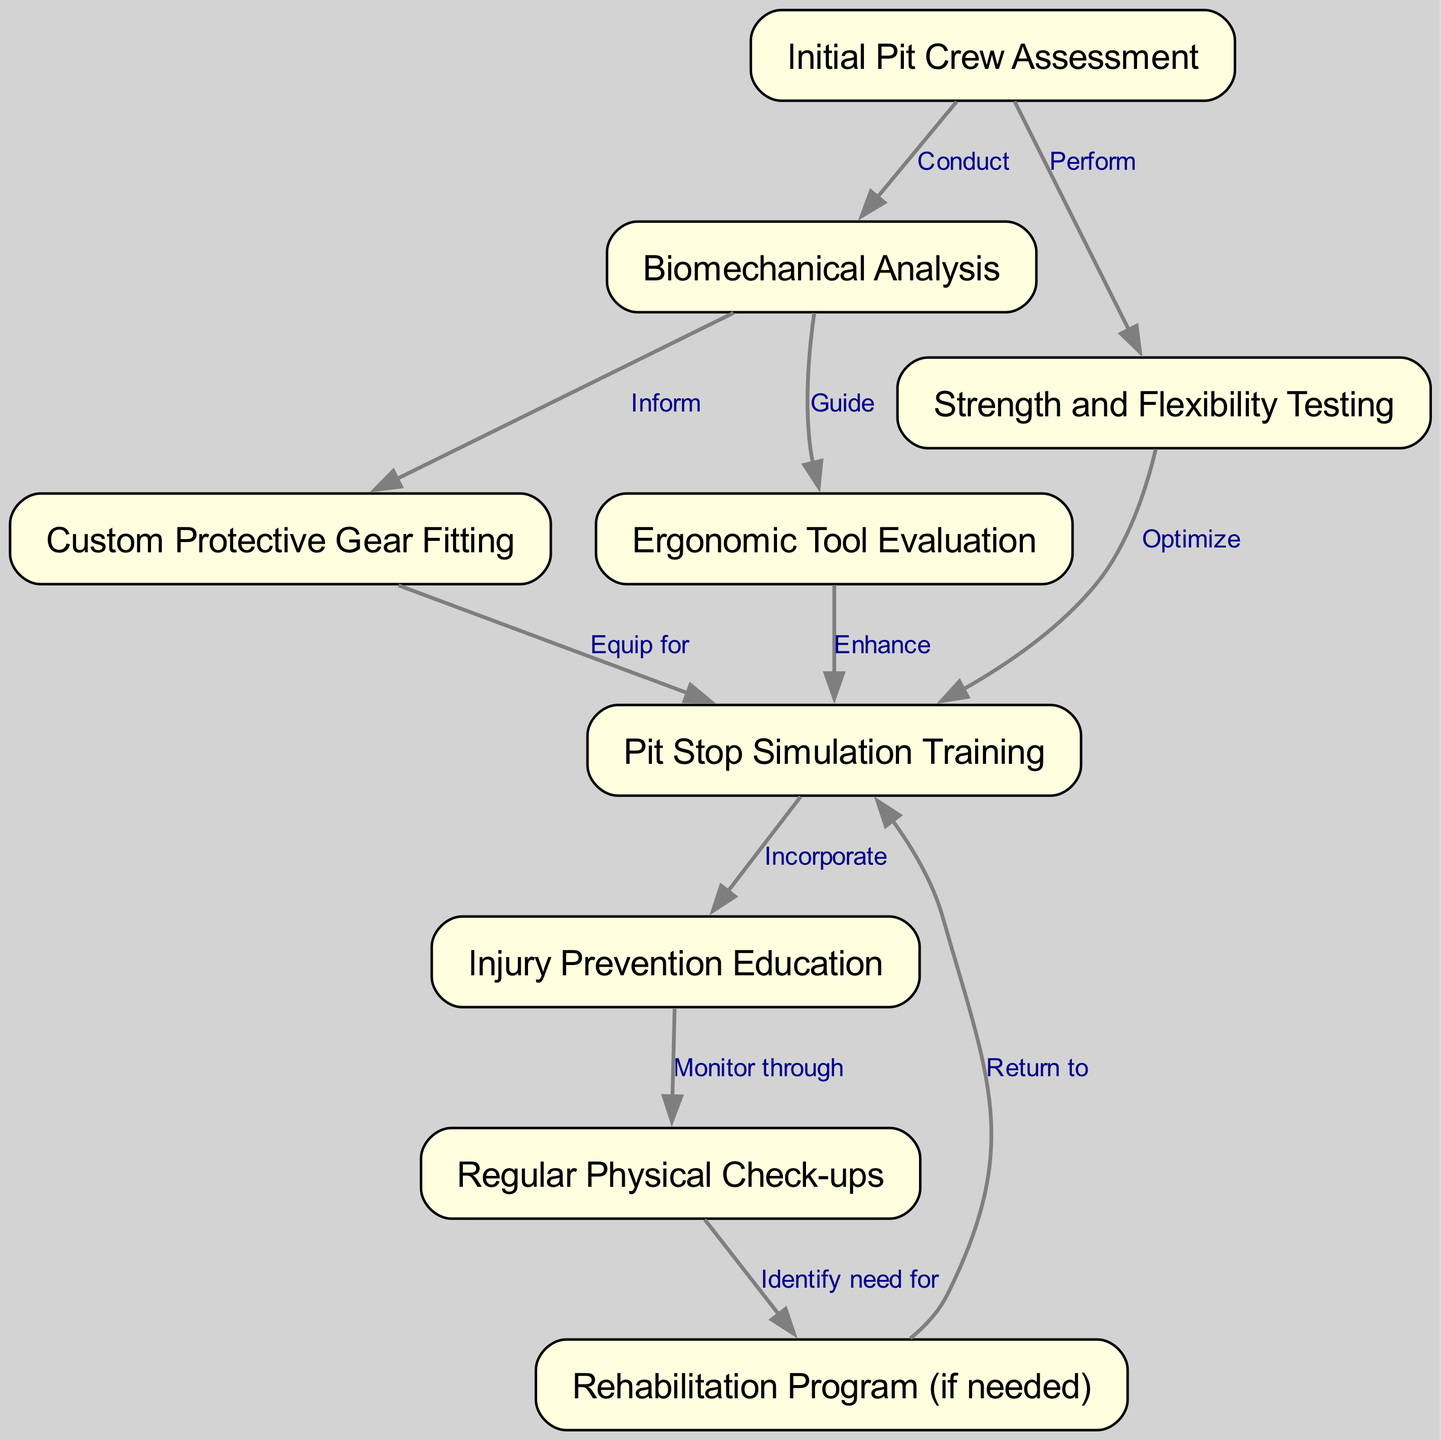What is the first node in the pathway? The first node is "Initial Pit Crew Assessment," as indicated by its position at the top of the diagram.
Answer: Initial Pit Crew Assessment How many nodes are present in the diagram? By counting each unique node listed in the diagram, we see there are nine nodes in total.
Answer: 9 Which node follows "Biomechanical Analysis"? The node that follows "Biomechanical Analysis" is "Custom Protective Gear Fitting." This can be confirmed by tracing the directed edge leading from node 2 to node 4.
Answer: Custom Protective Gear Fitting What is the relationship between "Strength and Flexibility Testing" and "Pit Stop Simulation Training"? The relationship is "Optimize," indicating that "Strength and Flexibility Testing" is utilized to improve or optimize the "Pit Stop Simulation Training." This is shown by the edge labeled with "Optimize" between nodes 3 and 6.
Answer: Optimize Which node prepares pit crew members for future physical check-ups? The node that prepares pit crew members for future physical check-ups is "Injury Prevention Education," indicated by the edge labeled "Monitor through" connecting it to "Regular Physical Check-ups."
Answer: Injury Prevention Education What two processes enhance pit stop simulation training? The two processes are "Custom Protective Gear Fitting" and "Ergonomic Tool Evaluation," as both nodes are connected to "Pit Stop Simulation Training" to enhance it. Node 4 equips for training, while node 5 enhances it.
Answer: Custom Protective Gear Fitting, Ergonomic Tool Evaluation What action is taken if a rehabilitation program is identified as needed? The action taken is to "Return to Pit Stop Simulation Training," as indicated by the directed edge from "Rehabilitation Program" back to "Pit Stop Simulation Training."
Answer: Return to Pit Stop Simulation Training How many edges connect nodes in the diagram? Counting all the edges that connect the nodes, we find there are ten edges in the diagram.
Answer: 10 